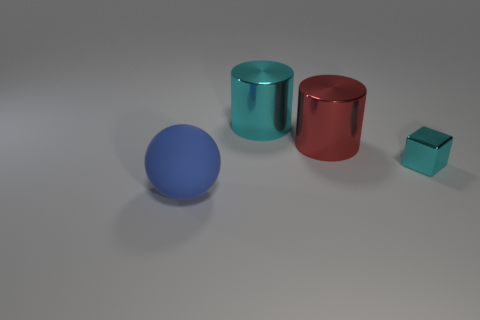Add 2 purple metallic cylinders. How many objects exist? 6 Subtract all cubes. How many objects are left? 3 Subtract all large shiny objects. Subtract all tiny cyan things. How many objects are left? 1 Add 1 big blue balls. How many big blue balls are left? 2 Add 3 large cyan metallic cylinders. How many large cyan metallic cylinders exist? 4 Subtract 0 red spheres. How many objects are left? 4 